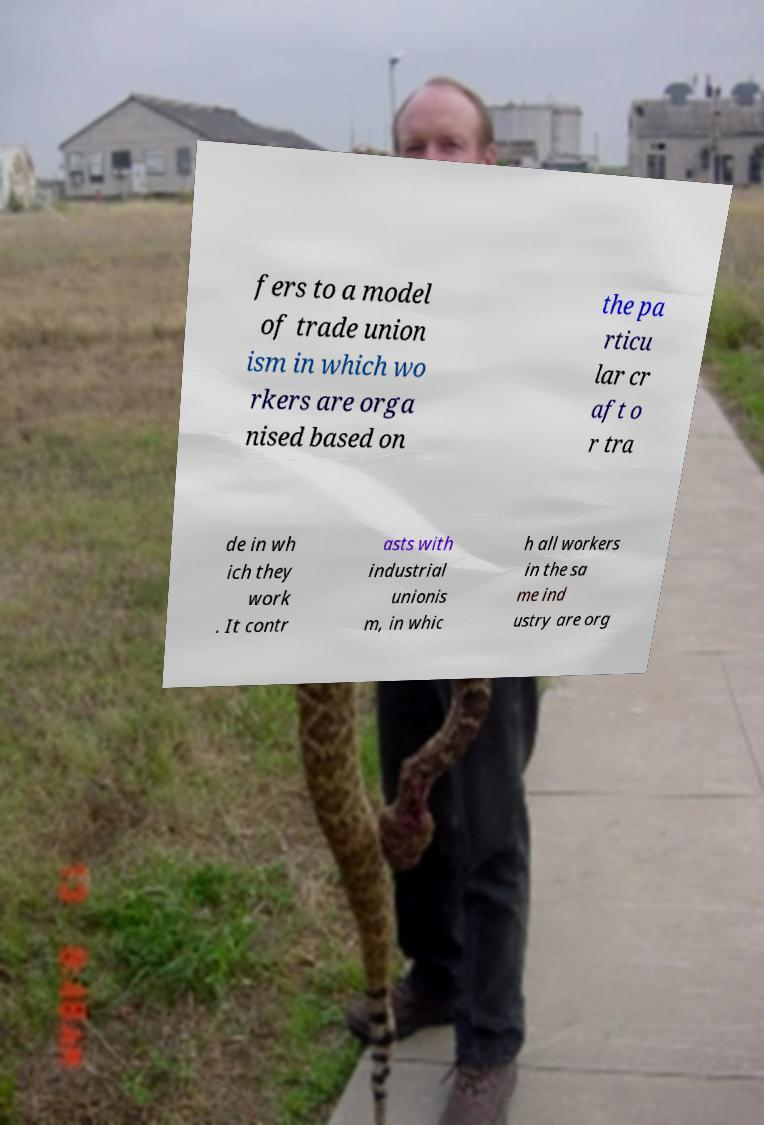What messages or text are displayed in this image? I need them in a readable, typed format. fers to a model of trade union ism in which wo rkers are orga nised based on the pa rticu lar cr aft o r tra de in wh ich they work . It contr asts with industrial unionis m, in whic h all workers in the sa me ind ustry are org 